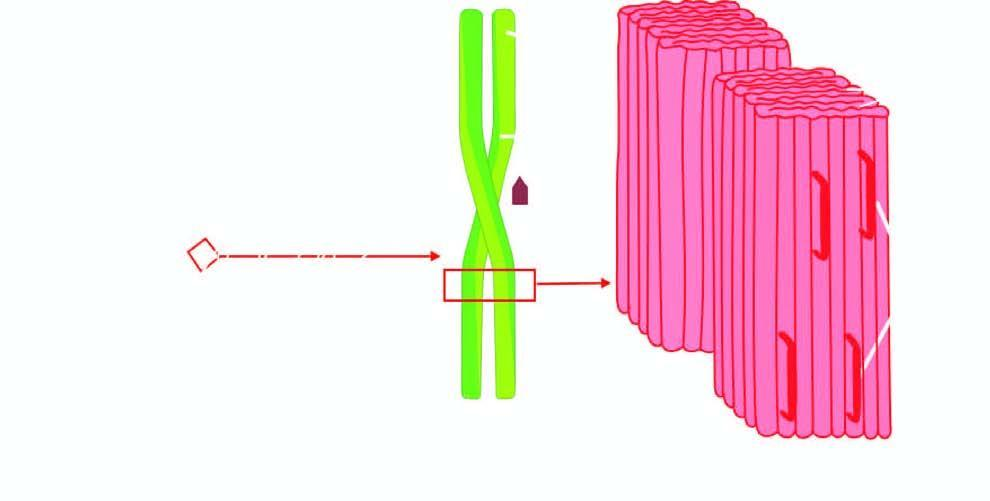what does p-component have?
Answer the question using a single word or phrase. Pentagonal or doughnut profile 